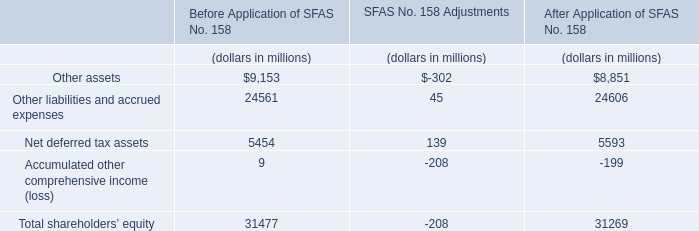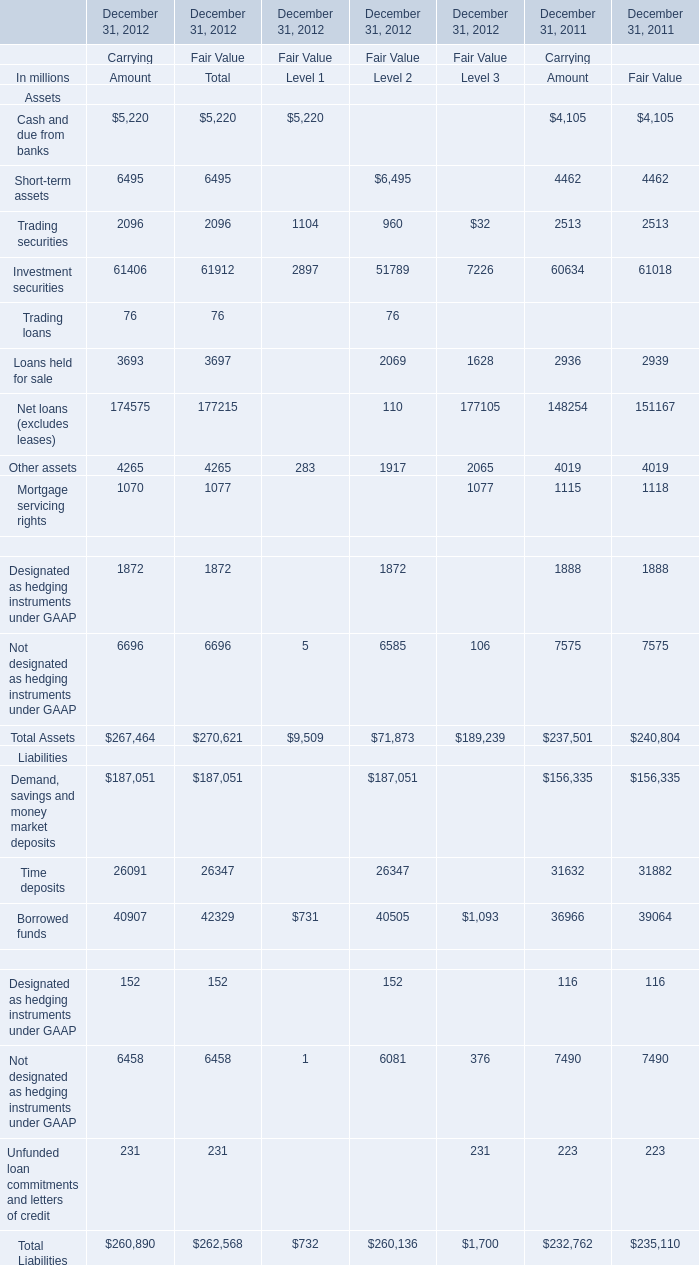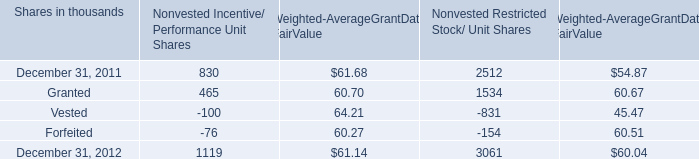how many shares were exercisable from dec 2010-dec 2011? 
Computations: (12337000 + 13397000)
Answer: 25734000.0. 